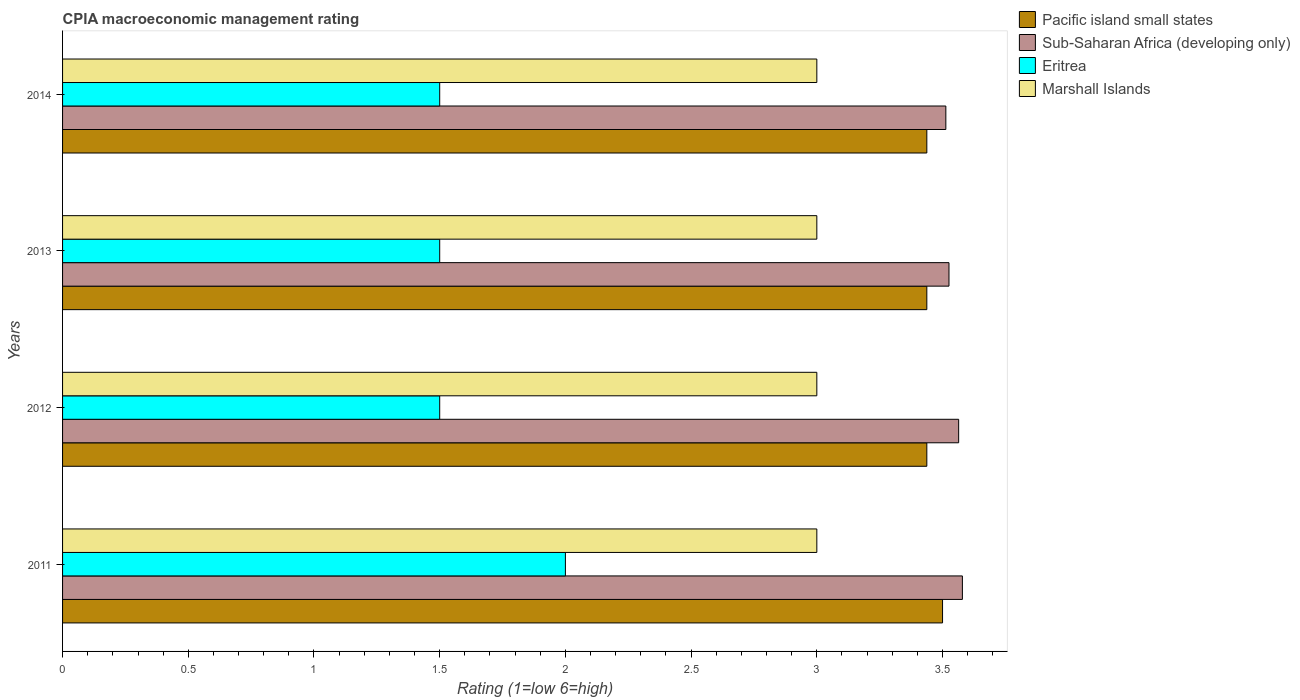How many groups of bars are there?
Your answer should be very brief. 4. Are the number of bars per tick equal to the number of legend labels?
Offer a terse response. Yes. Are the number of bars on each tick of the Y-axis equal?
Your response must be concise. Yes. What is the CPIA rating in Pacific island small states in 2013?
Provide a succinct answer. 3.44. In which year was the CPIA rating in Sub-Saharan Africa (developing only) maximum?
Offer a terse response. 2011. In which year was the CPIA rating in Eritrea minimum?
Offer a terse response. 2012. What is the total CPIA rating in Marshall Islands in the graph?
Provide a short and direct response. 12. What is the difference between the CPIA rating in Pacific island small states in 2011 and the CPIA rating in Sub-Saharan Africa (developing only) in 2012?
Give a very brief answer. -0.06. What is the average CPIA rating in Pacific island small states per year?
Provide a short and direct response. 3.45. In the year 2014, what is the difference between the CPIA rating in Marshall Islands and CPIA rating in Sub-Saharan Africa (developing only)?
Offer a very short reply. -0.51. What is the ratio of the CPIA rating in Eritrea in 2011 to that in 2012?
Your response must be concise. 1.33. Is the CPIA rating in Marshall Islands in 2011 less than that in 2014?
Your answer should be very brief. No. What is the difference between the highest and the lowest CPIA rating in Sub-Saharan Africa (developing only)?
Provide a succinct answer. 0.07. In how many years, is the CPIA rating in Marshall Islands greater than the average CPIA rating in Marshall Islands taken over all years?
Your answer should be very brief. 0. What does the 1st bar from the top in 2014 represents?
Your response must be concise. Marshall Islands. What does the 1st bar from the bottom in 2011 represents?
Provide a short and direct response. Pacific island small states. Is it the case that in every year, the sum of the CPIA rating in Pacific island small states and CPIA rating in Marshall Islands is greater than the CPIA rating in Sub-Saharan Africa (developing only)?
Your answer should be very brief. Yes. How many bars are there?
Offer a terse response. 16. Are all the bars in the graph horizontal?
Your response must be concise. Yes. How many years are there in the graph?
Offer a terse response. 4. What is the difference between two consecutive major ticks on the X-axis?
Your answer should be very brief. 0.5. Are the values on the major ticks of X-axis written in scientific E-notation?
Your answer should be compact. No. Does the graph contain any zero values?
Ensure brevity in your answer.  No. Where does the legend appear in the graph?
Offer a very short reply. Top right. What is the title of the graph?
Make the answer very short. CPIA macroeconomic management rating. What is the label or title of the X-axis?
Your response must be concise. Rating (1=low 6=high). What is the label or title of the Y-axis?
Make the answer very short. Years. What is the Rating (1=low 6=high) in Sub-Saharan Africa (developing only) in 2011?
Your answer should be very brief. 3.58. What is the Rating (1=low 6=high) of Marshall Islands in 2011?
Provide a short and direct response. 3. What is the Rating (1=low 6=high) of Pacific island small states in 2012?
Keep it short and to the point. 3.44. What is the Rating (1=low 6=high) of Sub-Saharan Africa (developing only) in 2012?
Your answer should be compact. 3.56. What is the Rating (1=low 6=high) in Pacific island small states in 2013?
Make the answer very short. 3.44. What is the Rating (1=low 6=high) of Sub-Saharan Africa (developing only) in 2013?
Keep it short and to the point. 3.53. What is the Rating (1=low 6=high) of Pacific island small states in 2014?
Provide a succinct answer. 3.44. What is the Rating (1=low 6=high) in Sub-Saharan Africa (developing only) in 2014?
Ensure brevity in your answer.  3.51. What is the Rating (1=low 6=high) of Marshall Islands in 2014?
Your response must be concise. 3. Across all years, what is the maximum Rating (1=low 6=high) in Pacific island small states?
Offer a terse response. 3.5. Across all years, what is the maximum Rating (1=low 6=high) in Sub-Saharan Africa (developing only)?
Offer a very short reply. 3.58. Across all years, what is the maximum Rating (1=low 6=high) in Eritrea?
Your answer should be very brief. 2. Across all years, what is the minimum Rating (1=low 6=high) in Pacific island small states?
Keep it short and to the point. 3.44. Across all years, what is the minimum Rating (1=low 6=high) in Sub-Saharan Africa (developing only)?
Offer a very short reply. 3.51. What is the total Rating (1=low 6=high) in Pacific island small states in the graph?
Offer a terse response. 13.81. What is the total Rating (1=low 6=high) of Sub-Saharan Africa (developing only) in the graph?
Your answer should be very brief. 14.18. What is the total Rating (1=low 6=high) in Eritrea in the graph?
Your answer should be compact. 6.5. What is the difference between the Rating (1=low 6=high) in Pacific island small states in 2011 and that in 2012?
Your answer should be very brief. 0.06. What is the difference between the Rating (1=low 6=high) of Sub-Saharan Africa (developing only) in 2011 and that in 2012?
Give a very brief answer. 0.01. What is the difference between the Rating (1=low 6=high) in Marshall Islands in 2011 and that in 2012?
Your answer should be very brief. 0. What is the difference between the Rating (1=low 6=high) in Pacific island small states in 2011 and that in 2013?
Offer a terse response. 0.06. What is the difference between the Rating (1=low 6=high) in Sub-Saharan Africa (developing only) in 2011 and that in 2013?
Offer a terse response. 0.05. What is the difference between the Rating (1=low 6=high) in Marshall Islands in 2011 and that in 2013?
Provide a short and direct response. 0. What is the difference between the Rating (1=low 6=high) of Pacific island small states in 2011 and that in 2014?
Your answer should be very brief. 0.06. What is the difference between the Rating (1=low 6=high) in Sub-Saharan Africa (developing only) in 2011 and that in 2014?
Offer a terse response. 0.07. What is the difference between the Rating (1=low 6=high) of Marshall Islands in 2011 and that in 2014?
Your answer should be very brief. 0. What is the difference between the Rating (1=low 6=high) of Sub-Saharan Africa (developing only) in 2012 and that in 2013?
Make the answer very short. 0.04. What is the difference between the Rating (1=low 6=high) in Eritrea in 2012 and that in 2013?
Your answer should be very brief. 0. What is the difference between the Rating (1=low 6=high) of Marshall Islands in 2012 and that in 2013?
Your answer should be very brief. 0. What is the difference between the Rating (1=low 6=high) of Pacific island small states in 2012 and that in 2014?
Your response must be concise. 0. What is the difference between the Rating (1=low 6=high) of Sub-Saharan Africa (developing only) in 2012 and that in 2014?
Keep it short and to the point. 0.05. What is the difference between the Rating (1=low 6=high) of Marshall Islands in 2012 and that in 2014?
Your answer should be very brief. 0. What is the difference between the Rating (1=low 6=high) of Pacific island small states in 2013 and that in 2014?
Your answer should be very brief. 0. What is the difference between the Rating (1=low 6=high) in Sub-Saharan Africa (developing only) in 2013 and that in 2014?
Your answer should be very brief. 0.01. What is the difference between the Rating (1=low 6=high) of Eritrea in 2013 and that in 2014?
Give a very brief answer. 0. What is the difference between the Rating (1=low 6=high) in Marshall Islands in 2013 and that in 2014?
Give a very brief answer. 0. What is the difference between the Rating (1=low 6=high) in Pacific island small states in 2011 and the Rating (1=low 6=high) in Sub-Saharan Africa (developing only) in 2012?
Your response must be concise. -0.06. What is the difference between the Rating (1=low 6=high) in Pacific island small states in 2011 and the Rating (1=low 6=high) in Marshall Islands in 2012?
Offer a very short reply. 0.5. What is the difference between the Rating (1=low 6=high) in Sub-Saharan Africa (developing only) in 2011 and the Rating (1=low 6=high) in Eritrea in 2012?
Your response must be concise. 2.08. What is the difference between the Rating (1=low 6=high) of Sub-Saharan Africa (developing only) in 2011 and the Rating (1=low 6=high) of Marshall Islands in 2012?
Offer a very short reply. 0.58. What is the difference between the Rating (1=low 6=high) in Pacific island small states in 2011 and the Rating (1=low 6=high) in Sub-Saharan Africa (developing only) in 2013?
Your answer should be compact. -0.03. What is the difference between the Rating (1=low 6=high) of Pacific island small states in 2011 and the Rating (1=low 6=high) of Marshall Islands in 2013?
Your response must be concise. 0.5. What is the difference between the Rating (1=low 6=high) in Sub-Saharan Africa (developing only) in 2011 and the Rating (1=low 6=high) in Eritrea in 2013?
Your answer should be very brief. 2.08. What is the difference between the Rating (1=low 6=high) in Sub-Saharan Africa (developing only) in 2011 and the Rating (1=low 6=high) in Marshall Islands in 2013?
Your answer should be very brief. 0.58. What is the difference between the Rating (1=low 6=high) in Eritrea in 2011 and the Rating (1=low 6=high) in Marshall Islands in 2013?
Provide a short and direct response. -1. What is the difference between the Rating (1=low 6=high) in Pacific island small states in 2011 and the Rating (1=low 6=high) in Sub-Saharan Africa (developing only) in 2014?
Offer a terse response. -0.01. What is the difference between the Rating (1=low 6=high) of Pacific island small states in 2011 and the Rating (1=low 6=high) of Eritrea in 2014?
Keep it short and to the point. 2. What is the difference between the Rating (1=low 6=high) of Sub-Saharan Africa (developing only) in 2011 and the Rating (1=low 6=high) of Eritrea in 2014?
Your answer should be very brief. 2.08. What is the difference between the Rating (1=low 6=high) in Sub-Saharan Africa (developing only) in 2011 and the Rating (1=low 6=high) in Marshall Islands in 2014?
Your answer should be compact. 0.58. What is the difference between the Rating (1=low 6=high) in Pacific island small states in 2012 and the Rating (1=low 6=high) in Sub-Saharan Africa (developing only) in 2013?
Keep it short and to the point. -0.09. What is the difference between the Rating (1=low 6=high) in Pacific island small states in 2012 and the Rating (1=low 6=high) in Eritrea in 2013?
Offer a very short reply. 1.94. What is the difference between the Rating (1=low 6=high) in Pacific island small states in 2012 and the Rating (1=low 6=high) in Marshall Islands in 2013?
Keep it short and to the point. 0.44. What is the difference between the Rating (1=low 6=high) in Sub-Saharan Africa (developing only) in 2012 and the Rating (1=low 6=high) in Eritrea in 2013?
Your answer should be very brief. 2.06. What is the difference between the Rating (1=low 6=high) in Sub-Saharan Africa (developing only) in 2012 and the Rating (1=low 6=high) in Marshall Islands in 2013?
Ensure brevity in your answer.  0.56. What is the difference between the Rating (1=low 6=high) of Eritrea in 2012 and the Rating (1=low 6=high) of Marshall Islands in 2013?
Your answer should be compact. -1.5. What is the difference between the Rating (1=low 6=high) of Pacific island small states in 2012 and the Rating (1=low 6=high) of Sub-Saharan Africa (developing only) in 2014?
Keep it short and to the point. -0.08. What is the difference between the Rating (1=low 6=high) in Pacific island small states in 2012 and the Rating (1=low 6=high) in Eritrea in 2014?
Keep it short and to the point. 1.94. What is the difference between the Rating (1=low 6=high) of Pacific island small states in 2012 and the Rating (1=low 6=high) of Marshall Islands in 2014?
Give a very brief answer. 0.44. What is the difference between the Rating (1=low 6=high) in Sub-Saharan Africa (developing only) in 2012 and the Rating (1=low 6=high) in Eritrea in 2014?
Your answer should be compact. 2.06. What is the difference between the Rating (1=low 6=high) in Sub-Saharan Africa (developing only) in 2012 and the Rating (1=low 6=high) in Marshall Islands in 2014?
Offer a very short reply. 0.56. What is the difference between the Rating (1=low 6=high) in Eritrea in 2012 and the Rating (1=low 6=high) in Marshall Islands in 2014?
Ensure brevity in your answer.  -1.5. What is the difference between the Rating (1=low 6=high) in Pacific island small states in 2013 and the Rating (1=low 6=high) in Sub-Saharan Africa (developing only) in 2014?
Ensure brevity in your answer.  -0.08. What is the difference between the Rating (1=low 6=high) of Pacific island small states in 2013 and the Rating (1=low 6=high) of Eritrea in 2014?
Keep it short and to the point. 1.94. What is the difference between the Rating (1=low 6=high) in Pacific island small states in 2013 and the Rating (1=low 6=high) in Marshall Islands in 2014?
Your answer should be very brief. 0.44. What is the difference between the Rating (1=low 6=high) of Sub-Saharan Africa (developing only) in 2013 and the Rating (1=low 6=high) of Eritrea in 2014?
Offer a very short reply. 2.03. What is the difference between the Rating (1=low 6=high) in Sub-Saharan Africa (developing only) in 2013 and the Rating (1=low 6=high) in Marshall Islands in 2014?
Make the answer very short. 0.53. What is the average Rating (1=low 6=high) of Pacific island small states per year?
Offer a terse response. 3.45. What is the average Rating (1=low 6=high) of Sub-Saharan Africa (developing only) per year?
Ensure brevity in your answer.  3.55. What is the average Rating (1=low 6=high) of Eritrea per year?
Offer a very short reply. 1.62. What is the average Rating (1=low 6=high) in Marshall Islands per year?
Provide a succinct answer. 3. In the year 2011, what is the difference between the Rating (1=low 6=high) of Pacific island small states and Rating (1=low 6=high) of Sub-Saharan Africa (developing only)?
Your answer should be compact. -0.08. In the year 2011, what is the difference between the Rating (1=low 6=high) of Pacific island small states and Rating (1=low 6=high) of Eritrea?
Offer a terse response. 1.5. In the year 2011, what is the difference between the Rating (1=low 6=high) of Pacific island small states and Rating (1=low 6=high) of Marshall Islands?
Your answer should be compact. 0.5. In the year 2011, what is the difference between the Rating (1=low 6=high) in Sub-Saharan Africa (developing only) and Rating (1=low 6=high) in Eritrea?
Ensure brevity in your answer.  1.58. In the year 2011, what is the difference between the Rating (1=low 6=high) of Sub-Saharan Africa (developing only) and Rating (1=low 6=high) of Marshall Islands?
Keep it short and to the point. 0.58. In the year 2011, what is the difference between the Rating (1=low 6=high) of Eritrea and Rating (1=low 6=high) of Marshall Islands?
Give a very brief answer. -1. In the year 2012, what is the difference between the Rating (1=low 6=high) in Pacific island small states and Rating (1=low 6=high) in Sub-Saharan Africa (developing only)?
Ensure brevity in your answer.  -0.13. In the year 2012, what is the difference between the Rating (1=low 6=high) of Pacific island small states and Rating (1=low 6=high) of Eritrea?
Offer a very short reply. 1.94. In the year 2012, what is the difference between the Rating (1=low 6=high) of Pacific island small states and Rating (1=low 6=high) of Marshall Islands?
Your answer should be compact. 0.44. In the year 2012, what is the difference between the Rating (1=low 6=high) of Sub-Saharan Africa (developing only) and Rating (1=low 6=high) of Eritrea?
Offer a terse response. 2.06. In the year 2012, what is the difference between the Rating (1=low 6=high) in Sub-Saharan Africa (developing only) and Rating (1=low 6=high) in Marshall Islands?
Offer a very short reply. 0.56. In the year 2012, what is the difference between the Rating (1=low 6=high) of Eritrea and Rating (1=low 6=high) of Marshall Islands?
Your response must be concise. -1.5. In the year 2013, what is the difference between the Rating (1=low 6=high) of Pacific island small states and Rating (1=low 6=high) of Sub-Saharan Africa (developing only)?
Ensure brevity in your answer.  -0.09. In the year 2013, what is the difference between the Rating (1=low 6=high) of Pacific island small states and Rating (1=low 6=high) of Eritrea?
Offer a very short reply. 1.94. In the year 2013, what is the difference between the Rating (1=low 6=high) of Pacific island small states and Rating (1=low 6=high) of Marshall Islands?
Your answer should be compact. 0.44. In the year 2013, what is the difference between the Rating (1=low 6=high) in Sub-Saharan Africa (developing only) and Rating (1=low 6=high) in Eritrea?
Keep it short and to the point. 2.03. In the year 2013, what is the difference between the Rating (1=low 6=high) in Sub-Saharan Africa (developing only) and Rating (1=low 6=high) in Marshall Islands?
Provide a short and direct response. 0.53. In the year 2014, what is the difference between the Rating (1=low 6=high) in Pacific island small states and Rating (1=low 6=high) in Sub-Saharan Africa (developing only)?
Ensure brevity in your answer.  -0.08. In the year 2014, what is the difference between the Rating (1=low 6=high) of Pacific island small states and Rating (1=low 6=high) of Eritrea?
Your answer should be very brief. 1.94. In the year 2014, what is the difference between the Rating (1=low 6=high) of Pacific island small states and Rating (1=low 6=high) of Marshall Islands?
Your answer should be very brief. 0.44. In the year 2014, what is the difference between the Rating (1=low 6=high) of Sub-Saharan Africa (developing only) and Rating (1=low 6=high) of Eritrea?
Offer a terse response. 2.01. In the year 2014, what is the difference between the Rating (1=low 6=high) in Sub-Saharan Africa (developing only) and Rating (1=low 6=high) in Marshall Islands?
Give a very brief answer. 0.51. In the year 2014, what is the difference between the Rating (1=low 6=high) in Eritrea and Rating (1=low 6=high) in Marshall Islands?
Offer a very short reply. -1.5. What is the ratio of the Rating (1=low 6=high) in Pacific island small states in 2011 to that in 2012?
Offer a very short reply. 1.02. What is the ratio of the Rating (1=low 6=high) in Eritrea in 2011 to that in 2012?
Offer a very short reply. 1.33. What is the ratio of the Rating (1=low 6=high) of Marshall Islands in 2011 to that in 2012?
Your response must be concise. 1. What is the ratio of the Rating (1=low 6=high) in Pacific island small states in 2011 to that in 2013?
Give a very brief answer. 1.02. What is the ratio of the Rating (1=low 6=high) of Sub-Saharan Africa (developing only) in 2011 to that in 2013?
Your answer should be very brief. 1.02. What is the ratio of the Rating (1=low 6=high) in Eritrea in 2011 to that in 2013?
Your answer should be compact. 1.33. What is the ratio of the Rating (1=low 6=high) of Pacific island small states in 2011 to that in 2014?
Your response must be concise. 1.02. What is the ratio of the Rating (1=low 6=high) of Sub-Saharan Africa (developing only) in 2011 to that in 2014?
Provide a succinct answer. 1.02. What is the ratio of the Rating (1=low 6=high) of Marshall Islands in 2011 to that in 2014?
Your response must be concise. 1. What is the ratio of the Rating (1=low 6=high) of Sub-Saharan Africa (developing only) in 2012 to that in 2013?
Offer a very short reply. 1.01. What is the ratio of the Rating (1=low 6=high) of Marshall Islands in 2012 to that in 2013?
Offer a very short reply. 1. What is the ratio of the Rating (1=low 6=high) of Sub-Saharan Africa (developing only) in 2012 to that in 2014?
Keep it short and to the point. 1.01. What is the ratio of the Rating (1=low 6=high) in Pacific island small states in 2013 to that in 2014?
Your response must be concise. 1. What is the ratio of the Rating (1=low 6=high) in Eritrea in 2013 to that in 2014?
Provide a short and direct response. 1. What is the difference between the highest and the second highest Rating (1=low 6=high) in Pacific island small states?
Your answer should be very brief. 0.06. What is the difference between the highest and the second highest Rating (1=low 6=high) in Sub-Saharan Africa (developing only)?
Provide a succinct answer. 0.01. What is the difference between the highest and the second highest Rating (1=low 6=high) of Marshall Islands?
Offer a terse response. 0. What is the difference between the highest and the lowest Rating (1=low 6=high) of Pacific island small states?
Give a very brief answer. 0.06. What is the difference between the highest and the lowest Rating (1=low 6=high) of Sub-Saharan Africa (developing only)?
Ensure brevity in your answer.  0.07. What is the difference between the highest and the lowest Rating (1=low 6=high) in Marshall Islands?
Give a very brief answer. 0. 